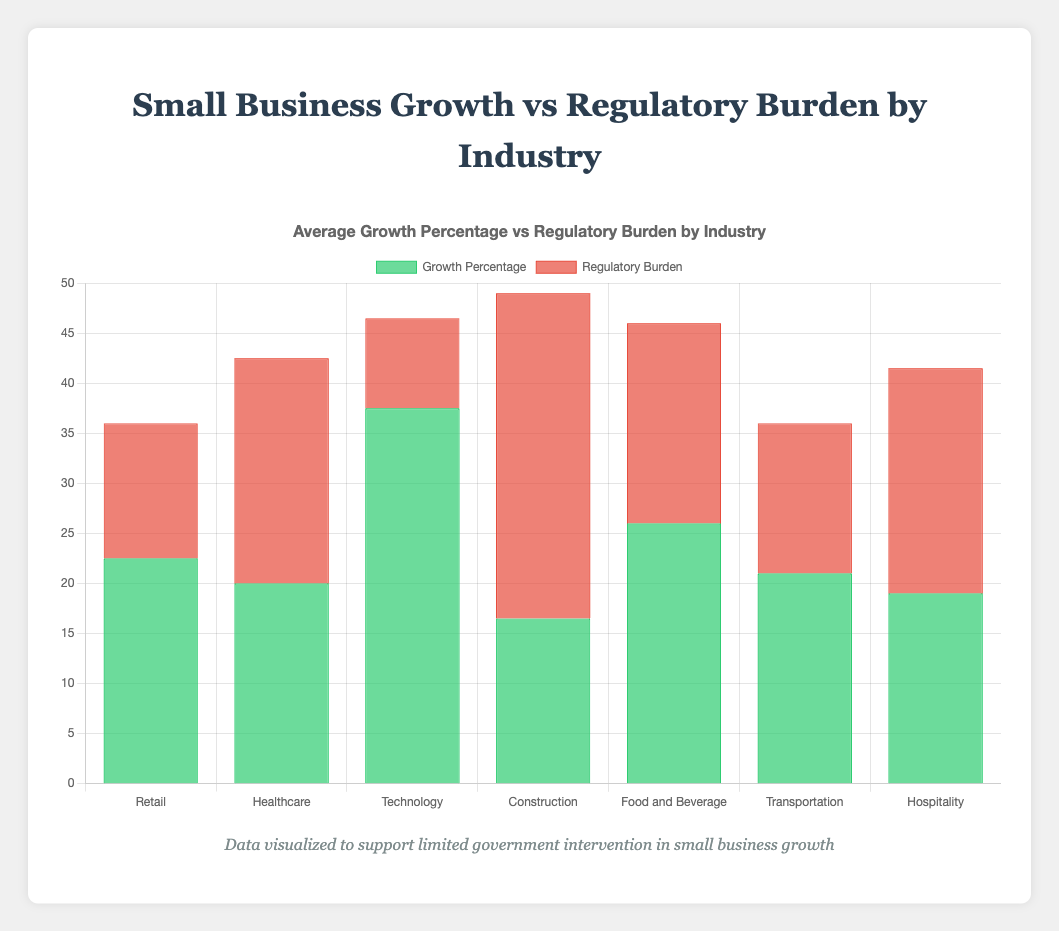What is the industry with the highest average growth percentage? To determine the industry with the highest average growth percentage, look at the green bars for each industry group and compare their heights. The Technology industry has the tallest green bars.
Answer: Technology Which industry has the highest regulatory burden compared to its growth percentage? To answer this, compare the red and green bars across each industry. The Construction industry has particularly high red bars compared to its green bars, indicating a high regulatory burden relative to its growth percentage.
Answer: Construction What is the total regulatory burden for the Healthcare industry? Sum the data values for the Healthcare regulatory burdens: 20 (Small Clinic A) + 25 (Small Clinic B) = 45.
Answer: 45 By how much does the regulatory burden for Construction exceed that of Technology? Calculate the average regulatory burden for Construction (30+35)/2 = 32.5 and for Technology (10+8)/2 = 9. Compare the two: 32.5 - 9 = 23.5.
Answer: 23.5 Which industry has the largest discrepancy between growth percentage and regulatory burden? By reviewing the bar heights, compare green and red bars for each industry. Technology shows the largest gap with significantly higher green bars (around 37.5) and relatively lower red bars (around 9).
Answer: Technology What is the combined growth percentage of the Retail industry businesses? Add the growth percentages for Retail businesses: 20 (Small Business A) + 25 (Small Business B) = 45.
Answer: 45 How does the regulatory burden of Food and Beverage compare to that of Hospitality? Average the regulatory burdens for both industries: Food and Beverage (18+22)/2 = 20, Hospitality (20+25)/2 = 22.5. Compare the two averages, 20 < 22.5.
Answer: Less What is the average growth percentage of the Transportation industry? Calculate the average: (19 + 23) / 2 = 21.
Answer: 21 